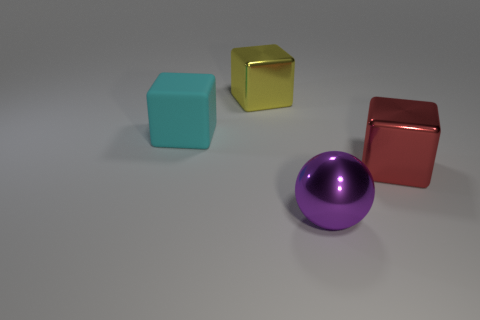How many objects are big yellow cubes that are behind the large red shiny object or shiny things to the left of the red shiny block?
Make the answer very short. 2. There is a metallic object behind the large metal thing that is to the right of the ball; what is its size?
Ensure brevity in your answer.  Large. There is a big metallic object that is to the left of the large ball; is it the same color as the big metal ball?
Keep it short and to the point. No. Is there a big purple metal thing of the same shape as the yellow object?
Make the answer very short. No. What color is the rubber cube that is the same size as the yellow metallic block?
Provide a succinct answer. Cyan. How big is the thing on the right side of the sphere?
Provide a succinct answer. Large. Is there a red metal block on the right side of the metallic block in front of the cyan matte thing?
Keep it short and to the point. No. Is the thing that is in front of the large red metallic object made of the same material as the cyan cube?
Offer a very short reply. No. What number of objects are both in front of the large red object and to the right of the large purple shiny object?
Keep it short and to the point. 0. What number of spheres are the same material as the yellow cube?
Your answer should be compact. 1. 